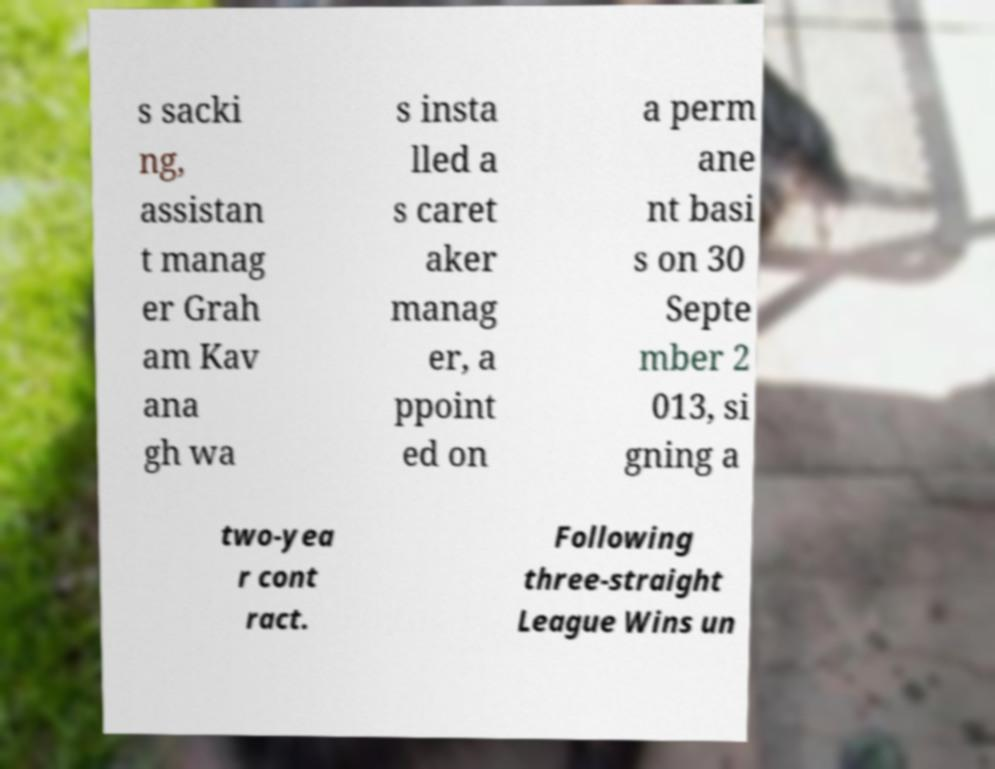Please identify and transcribe the text found in this image. s sacki ng, assistan t manag er Grah am Kav ana gh wa s insta lled a s caret aker manag er, a ppoint ed on a perm ane nt basi s on 30 Septe mber 2 013, si gning a two-yea r cont ract. Following three-straight League Wins un 